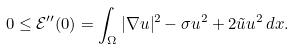Convert formula to latex. <formula><loc_0><loc_0><loc_500><loc_500>0 \leq { \mathcal { E } } ^ { \prime \prime } ( 0 ) = \int _ { \Omega } | \nabla u | ^ { 2 } - \sigma u ^ { 2 } + 2 \tilde { u } u ^ { 2 } \, d x .</formula> 